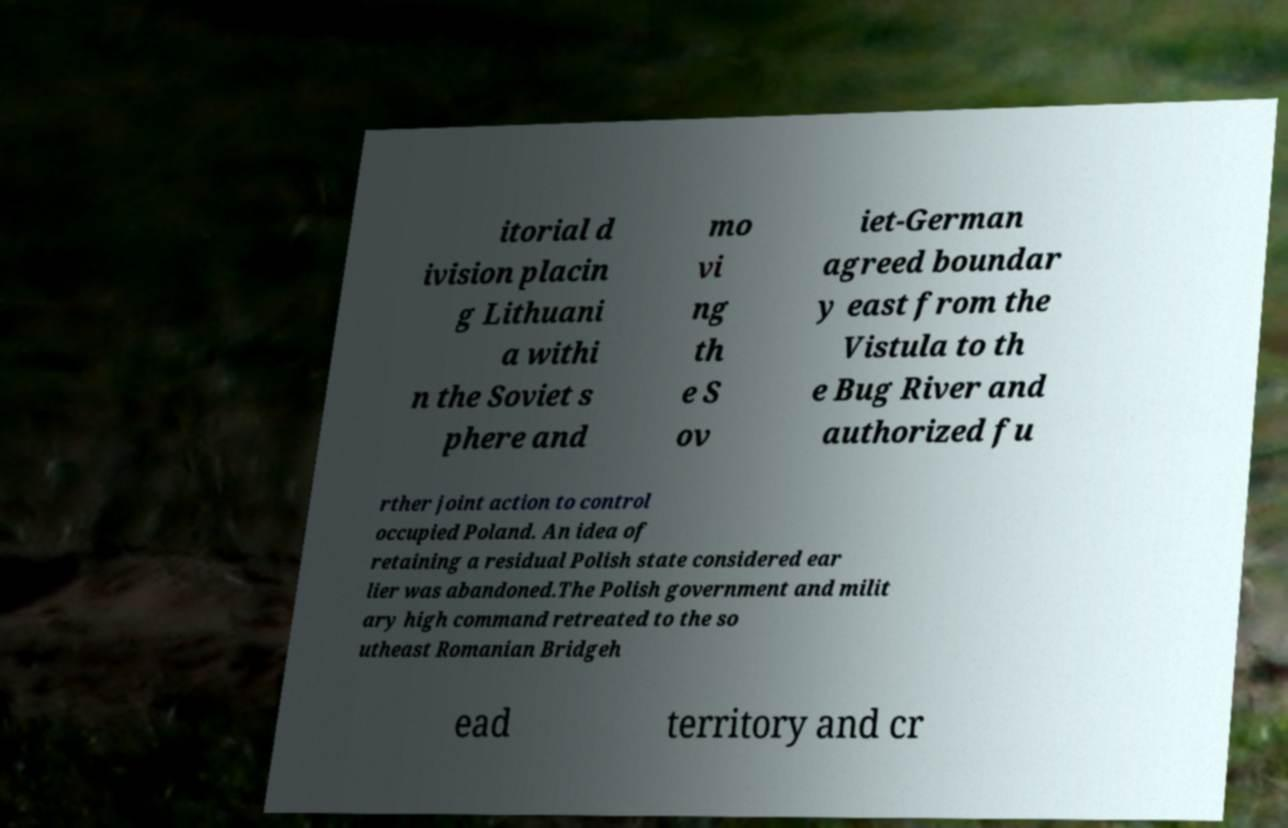For documentation purposes, I need the text within this image transcribed. Could you provide that? itorial d ivision placin g Lithuani a withi n the Soviet s phere and mo vi ng th e S ov iet-German agreed boundar y east from the Vistula to th e Bug River and authorized fu rther joint action to control occupied Poland. An idea of retaining a residual Polish state considered ear lier was abandoned.The Polish government and milit ary high command retreated to the so utheast Romanian Bridgeh ead territory and cr 